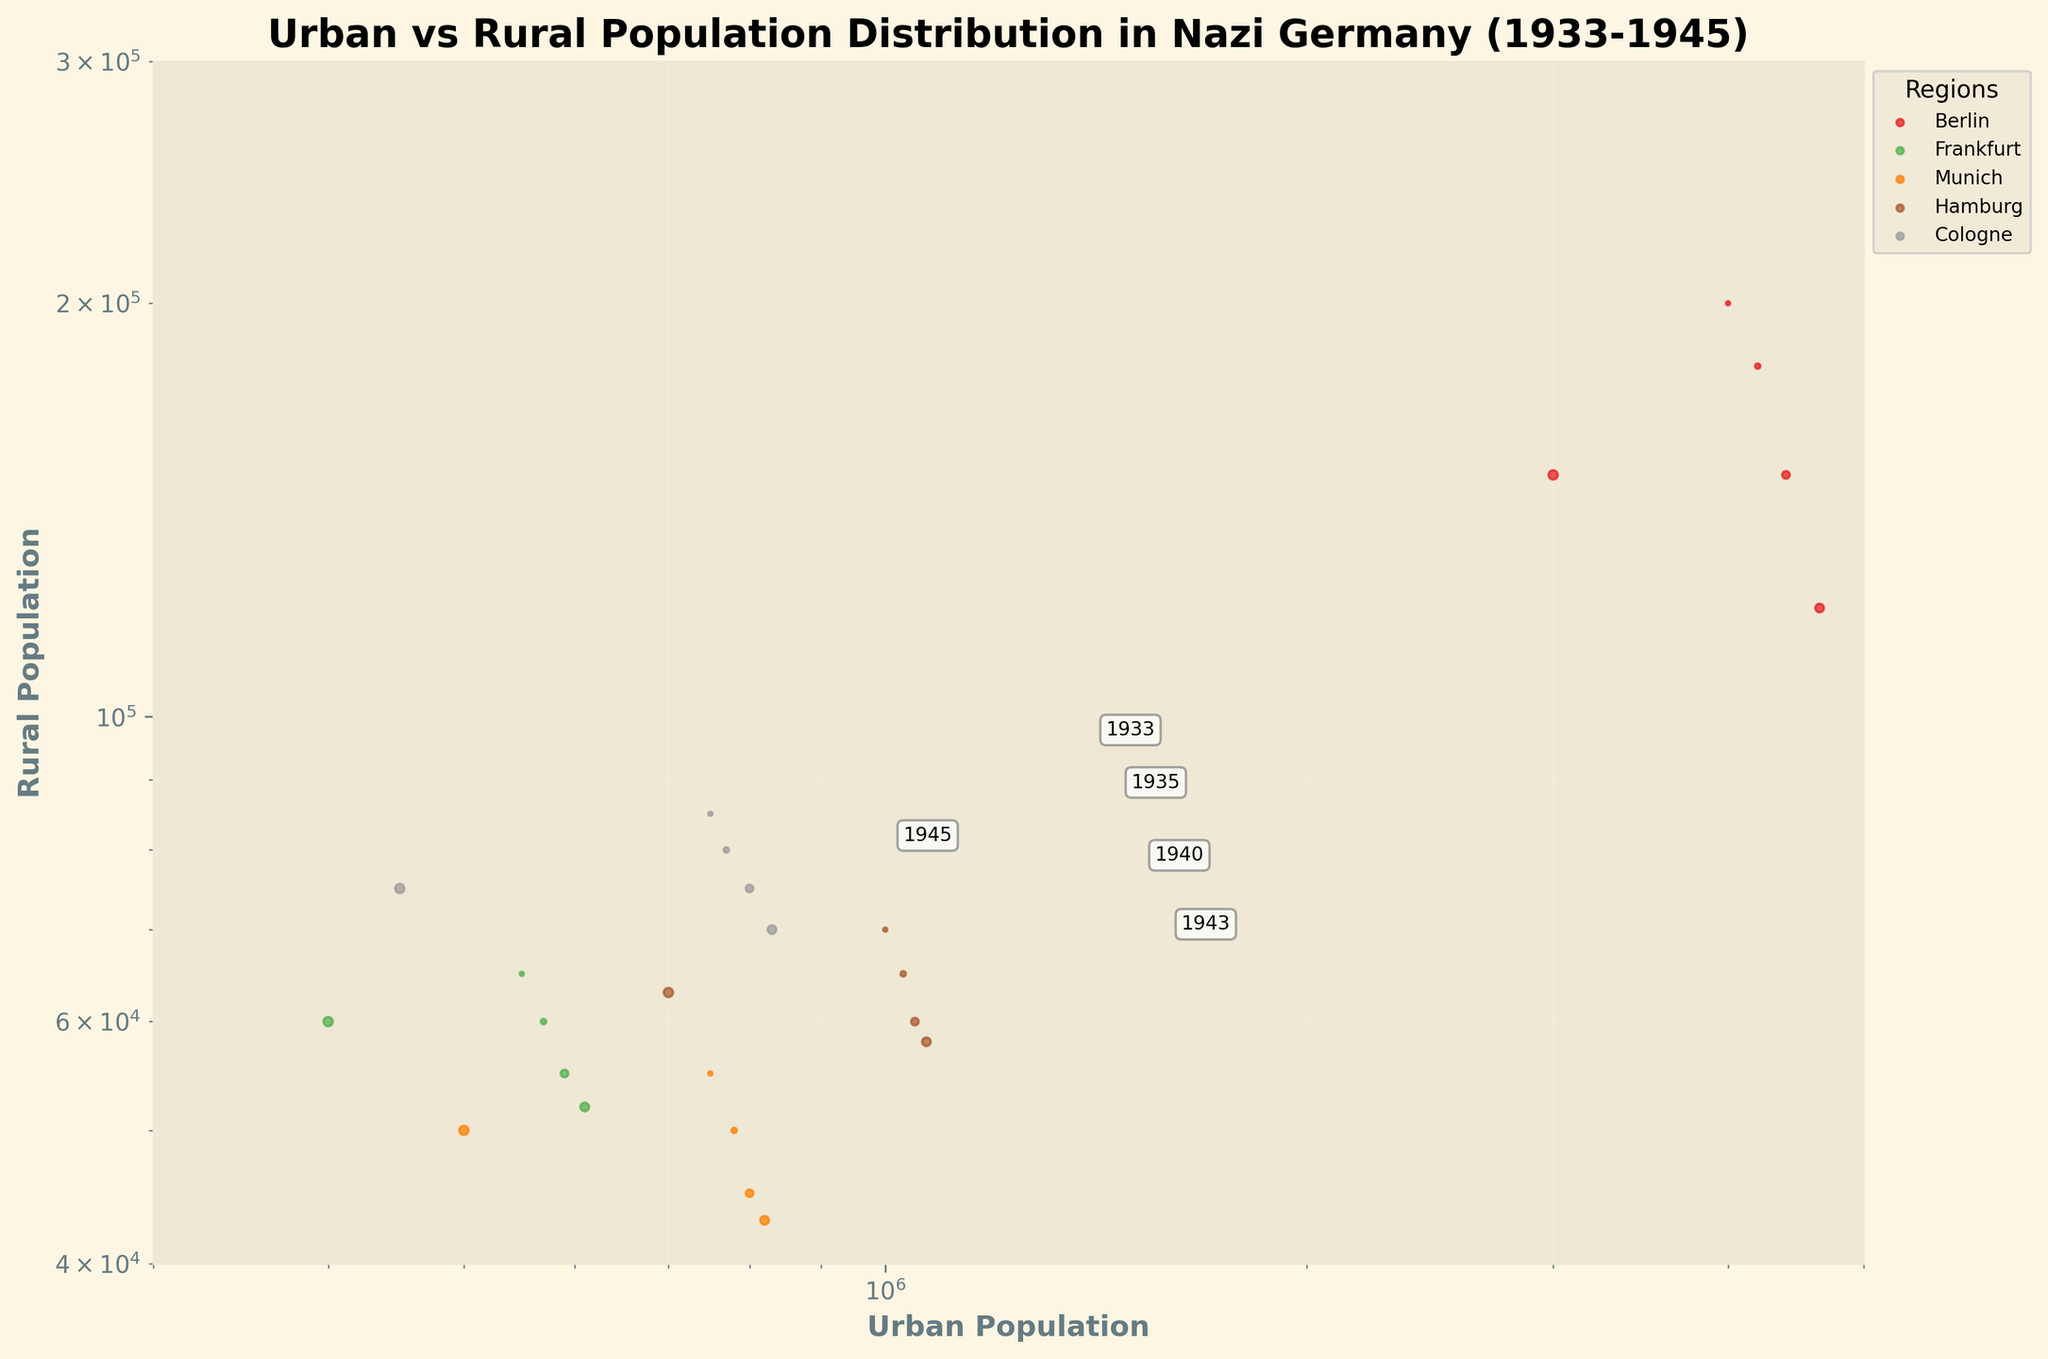What regions are represented in the scatter plot? By seeing the legend in the plot, we can determine which regions are represented. The legend should list all the regions with corresponding colors.
Answer: Berlin, Frankfurt, Munich, Hamburg, Cologne What is the overall trend between urban and rural populations from 1933 to 1945? By examining the scatter plot, we can observe the position and density of data points over time. Generally, we are looking for patterns such as increases or decreases in populations.
Answer: Urban populations generally increase until 1943 and then decrease by 1945. Rural populations decrease slightly or remain stable How does the urban population in Berlin change from 1933 to 1945? Look for Berlin data points on the scatter plot and note the urban population values for each year annotated on the plot.
Answer: 4000000 (1933) to 4200000 (1935) to 4400000 (1940) to 4650000 (1943) to 3000000 (1945) Which region had the smallest rural population in 1943? Identify the data points for all regions in the year 1943 and compare their rural population values.
Answer: Munich How does the rural population of Hamburg in 1933 compare to that in 1945? Find Hamburg data points for the years 1933 and 1945, and compare their rural population values by looking at their positions on the scatter plot.
Answer: 70000 (1933) to 63000 (1945) Which year had the highest average urban population across all regions? Find the urban population values for each region in the different years and calculate the average for each year. Then compare these averages.
Answer: 1943 What is the relationship between urban and rural populations in Berlin for the years provided? Examine the Berlin data points and see if there's a noticeable trend such as both increasing, one increasing while the other decreases, etc.
Answer: Urban population increases until 1943, then decreases in 1945 while rural population decreases overall Which region shows the most significant decline in urban population by 1945? Compare urban population values of all regions between their highest point before 1945 and their value in 1945. Identify the region with the largest decrease.
Answer: Berlin Do any regions have a stable rural population between 1933 and 1945? Check the rural population data points for each region from 1933 to 1945 and assess whether they remain roughly constant.
Answer: No region has a completely stable rural population; all show some variation Which region consistently had the lowest urban population? Find the region with the lowest urban population in each year and see if any region consistently has the lowest urban population.
Answer: Frankfurt 